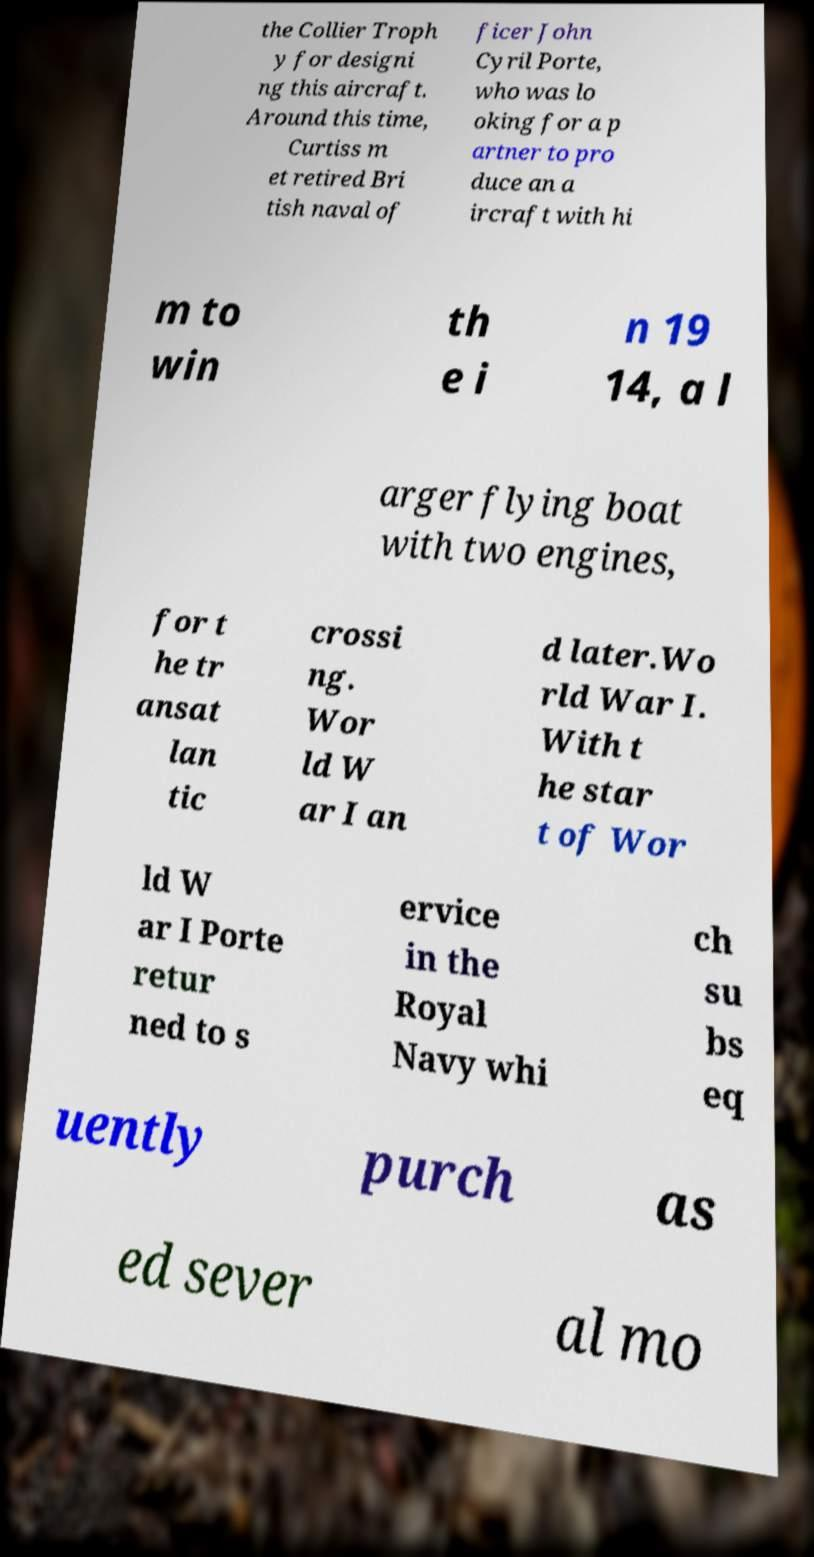Could you extract and type out the text from this image? the Collier Troph y for designi ng this aircraft. Around this time, Curtiss m et retired Bri tish naval of ficer John Cyril Porte, who was lo oking for a p artner to pro duce an a ircraft with hi m to win th e i n 19 14, a l arger flying boat with two engines, for t he tr ansat lan tic crossi ng. Wor ld W ar I an d later.Wo rld War I. With t he star t of Wor ld W ar I Porte retur ned to s ervice in the Royal Navy whi ch su bs eq uently purch as ed sever al mo 